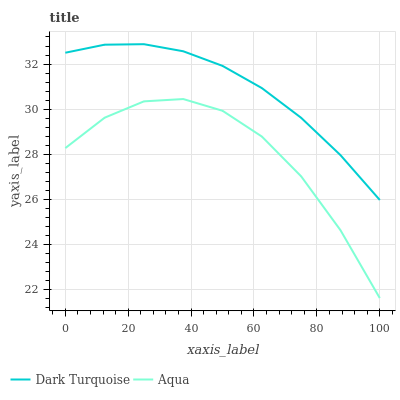Does Aqua have the minimum area under the curve?
Answer yes or no. Yes. Does Dark Turquoise have the maximum area under the curve?
Answer yes or no. Yes. Does Aqua have the maximum area under the curve?
Answer yes or no. No. Is Dark Turquoise the smoothest?
Answer yes or no. Yes. Is Aqua the roughest?
Answer yes or no. Yes. Is Aqua the smoothest?
Answer yes or no. No. Does Dark Turquoise have the highest value?
Answer yes or no. Yes. Does Aqua have the highest value?
Answer yes or no. No. Is Aqua less than Dark Turquoise?
Answer yes or no. Yes. Is Dark Turquoise greater than Aqua?
Answer yes or no. Yes. Does Aqua intersect Dark Turquoise?
Answer yes or no. No. 